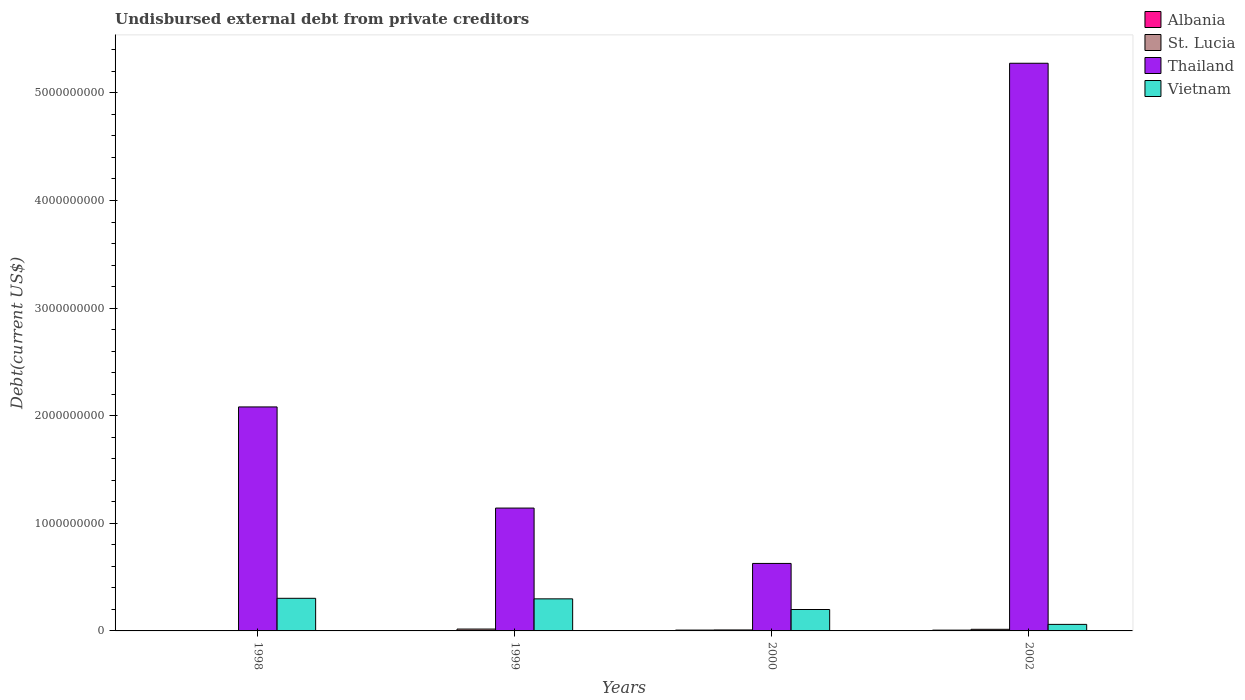How many different coloured bars are there?
Offer a terse response. 4. Are the number of bars per tick equal to the number of legend labels?
Give a very brief answer. Yes. Are the number of bars on each tick of the X-axis equal?
Make the answer very short. Yes. How many bars are there on the 4th tick from the left?
Keep it short and to the point. 4. In how many cases, is the number of bars for a given year not equal to the number of legend labels?
Offer a very short reply. 0. What is the total debt in Albania in 2000?
Offer a terse response. 7.78e+06. Across all years, what is the maximum total debt in Vietnam?
Offer a very short reply. 3.03e+08. Across all years, what is the minimum total debt in Thailand?
Keep it short and to the point. 6.27e+08. In which year was the total debt in Thailand maximum?
Keep it short and to the point. 2002. In which year was the total debt in Albania minimum?
Ensure brevity in your answer.  1999. What is the total total debt in Albania in the graph?
Make the answer very short. 1.59e+07. What is the difference between the total debt in St. Lucia in 1998 and that in 1999?
Your response must be concise. -1.43e+07. What is the difference between the total debt in Albania in 2000 and the total debt in St. Lucia in 1998?
Give a very brief answer. 4.71e+06. What is the average total debt in Albania per year?
Provide a succinct answer. 3.97e+06. In the year 1999, what is the difference between the total debt in Thailand and total debt in Albania?
Your answer should be compact. 1.14e+09. In how many years, is the total debt in Albania greater than 5200000000 US$?
Offer a terse response. 0. What is the ratio of the total debt in Vietnam in 1998 to that in 2002?
Provide a succinct answer. 4.99. What is the difference between the highest and the second highest total debt in Vietnam?
Ensure brevity in your answer.  5.08e+06. What is the difference between the highest and the lowest total debt in Vietnam?
Your answer should be compact. 2.42e+08. In how many years, is the total debt in Thailand greater than the average total debt in Thailand taken over all years?
Ensure brevity in your answer.  1. Is the sum of the total debt in Vietnam in 1999 and 2000 greater than the maximum total debt in St. Lucia across all years?
Offer a terse response. Yes. What does the 2nd bar from the left in 1999 represents?
Your answer should be very brief. St. Lucia. What does the 2nd bar from the right in 2000 represents?
Offer a very short reply. Thailand. How many bars are there?
Provide a short and direct response. 16. Are all the bars in the graph horizontal?
Your response must be concise. No. Are the values on the major ticks of Y-axis written in scientific E-notation?
Offer a very short reply. No. Does the graph contain grids?
Provide a short and direct response. No. How are the legend labels stacked?
Offer a terse response. Vertical. What is the title of the graph?
Your response must be concise. Undisbursed external debt from private creditors. Does "Maldives" appear as one of the legend labels in the graph?
Your answer should be compact. No. What is the label or title of the Y-axis?
Your response must be concise. Debt(current US$). What is the Debt(current US$) of Albania in 1998?
Provide a short and direct response. 4.29e+05. What is the Debt(current US$) of St. Lucia in 1998?
Your answer should be compact. 3.07e+06. What is the Debt(current US$) of Thailand in 1998?
Your response must be concise. 2.08e+09. What is the Debt(current US$) of Vietnam in 1998?
Provide a succinct answer. 3.03e+08. What is the Debt(current US$) in Albania in 1999?
Your response must be concise. 3.67e+05. What is the Debt(current US$) of St. Lucia in 1999?
Your answer should be very brief. 1.74e+07. What is the Debt(current US$) in Thailand in 1999?
Provide a succinct answer. 1.14e+09. What is the Debt(current US$) in Vietnam in 1999?
Make the answer very short. 2.98e+08. What is the Debt(current US$) of Albania in 2000?
Your answer should be compact. 7.78e+06. What is the Debt(current US$) of St. Lucia in 2000?
Your answer should be very brief. 9.00e+06. What is the Debt(current US$) of Thailand in 2000?
Provide a short and direct response. 6.27e+08. What is the Debt(current US$) of Vietnam in 2000?
Ensure brevity in your answer.  1.99e+08. What is the Debt(current US$) of Albania in 2002?
Provide a succinct answer. 7.31e+06. What is the Debt(current US$) in St. Lucia in 2002?
Offer a very short reply. 1.50e+07. What is the Debt(current US$) of Thailand in 2002?
Your response must be concise. 5.28e+09. What is the Debt(current US$) in Vietnam in 2002?
Give a very brief answer. 6.08e+07. Across all years, what is the maximum Debt(current US$) in Albania?
Ensure brevity in your answer.  7.78e+06. Across all years, what is the maximum Debt(current US$) in St. Lucia?
Offer a terse response. 1.74e+07. Across all years, what is the maximum Debt(current US$) of Thailand?
Give a very brief answer. 5.28e+09. Across all years, what is the maximum Debt(current US$) in Vietnam?
Your response must be concise. 3.03e+08. Across all years, what is the minimum Debt(current US$) in Albania?
Provide a succinct answer. 3.67e+05. Across all years, what is the minimum Debt(current US$) in St. Lucia?
Provide a succinct answer. 3.07e+06. Across all years, what is the minimum Debt(current US$) of Thailand?
Give a very brief answer. 6.27e+08. Across all years, what is the minimum Debt(current US$) of Vietnam?
Your answer should be compact. 6.08e+07. What is the total Debt(current US$) in Albania in the graph?
Ensure brevity in your answer.  1.59e+07. What is the total Debt(current US$) of St. Lucia in the graph?
Offer a very short reply. 4.45e+07. What is the total Debt(current US$) of Thailand in the graph?
Give a very brief answer. 9.13e+09. What is the total Debt(current US$) of Vietnam in the graph?
Provide a short and direct response. 8.61e+08. What is the difference between the Debt(current US$) in Albania in 1998 and that in 1999?
Keep it short and to the point. 6.20e+04. What is the difference between the Debt(current US$) in St. Lucia in 1998 and that in 1999?
Your response must be concise. -1.43e+07. What is the difference between the Debt(current US$) of Thailand in 1998 and that in 1999?
Ensure brevity in your answer.  9.40e+08. What is the difference between the Debt(current US$) of Vietnam in 1998 and that in 1999?
Your answer should be compact. 5.08e+06. What is the difference between the Debt(current US$) of Albania in 1998 and that in 2000?
Offer a terse response. -7.35e+06. What is the difference between the Debt(current US$) of St. Lucia in 1998 and that in 2000?
Your answer should be compact. -5.93e+06. What is the difference between the Debt(current US$) of Thailand in 1998 and that in 2000?
Provide a short and direct response. 1.45e+09. What is the difference between the Debt(current US$) in Vietnam in 1998 and that in 2000?
Ensure brevity in your answer.  1.04e+08. What is the difference between the Debt(current US$) in Albania in 1998 and that in 2002?
Make the answer very short. -6.88e+06. What is the difference between the Debt(current US$) of St. Lucia in 1998 and that in 2002?
Your answer should be compact. -1.19e+07. What is the difference between the Debt(current US$) in Thailand in 1998 and that in 2002?
Ensure brevity in your answer.  -3.19e+09. What is the difference between the Debt(current US$) in Vietnam in 1998 and that in 2002?
Provide a short and direct response. 2.42e+08. What is the difference between the Debt(current US$) of Albania in 1999 and that in 2000?
Make the answer very short. -7.41e+06. What is the difference between the Debt(current US$) in St. Lucia in 1999 and that in 2000?
Ensure brevity in your answer.  8.40e+06. What is the difference between the Debt(current US$) in Thailand in 1999 and that in 2000?
Your response must be concise. 5.14e+08. What is the difference between the Debt(current US$) in Vietnam in 1999 and that in 2000?
Your answer should be very brief. 9.90e+07. What is the difference between the Debt(current US$) of Albania in 1999 and that in 2002?
Provide a short and direct response. -6.95e+06. What is the difference between the Debt(current US$) of St. Lucia in 1999 and that in 2002?
Provide a succinct answer. 2.40e+06. What is the difference between the Debt(current US$) of Thailand in 1999 and that in 2002?
Your answer should be compact. -4.13e+09. What is the difference between the Debt(current US$) in Vietnam in 1999 and that in 2002?
Offer a terse response. 2.37e+08. What is the difference between the Debt(current US$) in Albania in 2000 and that in 2002?
Your response must be concise. 4.66e+05. What is the difference between the Debt(current US$) of St. Lucia in 2000 and that in 2002?
Offer a very short reply. -6.00e+06. What is the difference between the Debt(current US$) of Thailand in 2000 and that in 2002?
Provide a succinct answer. -4.65e+09. What is the difference between the Debt(current US$) of Vietnam in 2000 and that in 2002?
Your answer should be very brief. 1.38e+08. What is the difference between the Debt(current US$) of Albania in 1998 and the Debt(current US$) of St. Lucia in 1999?
Make the answer very short. -1.70e+07. What is the difference between the Debt(current US$) of Albania in 1998 and the Debt(current US$) of Thailand in 1999?
Make the answer very short. -1.14e+09. What is the difference between the Debt(current US$) in Albania in 1998 and the Debt(current US$) in Vietnam in 1999?
Provide a succinct answer. -2.98e+08. What is the difference between the Debt(current US$) of St. Lucia in 1998 and the Debt(current US$) of Thailand in 1999?
Give a very brief answer. -1.14e+09. What is the difference between the Debt(current US$) in St. Lucia in 1998 and the Debt(current US$) in Vietnam in 1999?
Provide a short and direct response. -2.95e+08. What is the difference between the Debt(current US$) of Thailand in 1998 and the Debt(current US$) of Vietnam in 1999?
Your response must be concise. 1.78e+09. What is the difference between the Debt(current US$) in Albania in 1998 and the Debt(current US$) in St. Lucia in 2000?
Ensure brevity in your answer.  -8.57e+06. What is the difference between the Debt(current US$) in Albania in 1998 and the Debt(current US$) in Thailand in 2000?
Provide a short and direct response. -6.27e+08. What is the difference between the Debt(current US$) in Albania in 1998 and the Debt(current US$) in Vietnam in 2000?
Offer a very short reply. -1.99e+08. What is the difference between the Debt(current US$) in St. Lucia in 1998 and the Debt(current US$) in Thailand in 2000?
Give a very brief answer. -6.24e+08. What is the difference between the Debt(current US$) of St. Lucia in 1998 and the Debt(current US$) of Vietnam in 2000?
Make the answer very short. -1.96e+08. What is the difference between the Debt(current US$) in Thailand in 1998 and the Debt(current US$) in Vietnam in 2000?
Provide a short and direct response. 1.88e+09. What is the difference between the Debt(current US$) in Albania in 1998 and the Debt(current US$) in St. Lucia in 2002?
Offer a terse response. -1.46e+07. What is the difference between the Debt(current US$) of Albania in 1998 and the Debt(current US$) of Thailand in 2002?
Provide a short and direct response. -5.28e+09. What is the difference between the Debt(current US$) of Albania in 1998 and the Debt(current US$) of Vietnam in 2002?
Offer a very short reply. -6.03e+07. What is the difference between the Debt(current US$) of St. Lucia in 1998 and the Debt(current US$) of Thailand in 2002?
Ensure brevity in your answer.  -5.27e+09. What is the difference between the Debt(current US$) of St. Lucia in 1998 and the Debt(current US$) of Vietnam in 2002?
Your answer should be very brief. -5.77e+07. What is the difference between the Debt(current US$) of Thailand in 1998 and the Debt(current US$) of Vietnam in 2002?
Make the answer very short. 2.02e+09. What is the difference between the Debt(current US$) in Albania in 1999 and the Debt(current US$) in St. Lucia in 2000?
Ensure brevity in your answer.  -8.63e+06. What is the difference between the Debt(current US$) of Albania in 1999 and the Debt(current US$) of Thailand in 2000?
Make the answer very short. -6.27e+08. What is the difference between the Debt(current US$) of Albania in 1999 and the Debt(current US$) of Vietnam in 2000?
Provide a short and direct response. -1.99e+08. What is the difference between the Debt(current US$) of St. Lucia in 1999 and the Debt(current US$) of Thailand in 2000?
Provide a short and direct response. -6.10e+08. What is the difference between the Debt(current US$) in St. Lucia in 1999 and the Debt(current US$) in Vietnam in 2000?
Give a very brief answer. -1.82e+08. What is the difference between the Debt(current US$) in Thailand in 1999 and the Debt(current US$) in Vietnam in 2000?
Ensure brevity in your answer.  9.43e+08. What is the difference between the Debt(current US$) of Albania in 1999 and the Debt(current US$) of St. Lucia in 2002?
Keep it short and to the point. -1.46e+07. What is the difference between the Debt(current US$) of Albania in 1999 and the Debt(current US$) of Thailand in 2002?
Keep it short and to the point. -5.28e+09. What is the difference between the Debt(current US$) in Albania in 1999 and the Debt(current US$) in Vietnam in 2002?
Provide a short and direct response. -6.04e+07. What is the difference between the Debt(current US$) in St. Lucia in 1999 and the Debt(current US$) in Thailand in 2002?
Make the answer very short. -5.26e+09. What is the difference between the Debt(current US$) in St. Lucia in 1999 and the Debt(current US$) in Vietnam in 2002?
Provide a succinct answer. -4.34e+07. What is the difference between the Debt(current US$) of Thailand in 1999 and the Debt(current US$) of Vietnam in 2002?
Ensure brevity in your answer.  1.08e+09. What is the difference between the Debt(current US$) of Albania in 2000 and the Debt(current US$) of St. Lucia in 2002?
Provide a succinct answer. -7.22e+06. What is the difference between the Debt(current US$) in Albania in 2000 and the Debt(current US$) in Thailand in 2002?
Keep it short and to the point. -5.27e+09. What is the difference between the Debt(current US$) of Albania in 2000 and the Debt(current US$) of Vietnam in 2002?
Ensure brevity in your answer.  -5.30e+07. What is the difference between the Debt(current US$) in St. Lucia in 2000 and the Debt(current US$) in Thailand in 2002?
Provide a short and direct response. -5.27e+09. What is the difference between the Debt(current US$) in St. Lucia in 2000 and the Debt(current US$) in Vietnam in 2002?
Offer a very short reply. -5.18e+07. What is the difference between the Debt(current US$) in Thailand in 2000 and the Debt(current US$) in Vietnam in 2002?
Offer a terse response. 5.67e+08. What is the average Debt(current US$) in Albania per year?
Ensure brevity in your answer.  3.97e+06. What is the average Debt(current US$) in St. Lucia per year?
Your answer should be compact. 1.11e+07. What is the average Debt(current US$) of Thailand per year?
Offer a very short reply. 2.28e+09. What is the average Debt(current US$) of Vietnam per year?
Provide a succinct answer. 2.15e+08. In the year 1998, what is the difference between the Debt(current US$) in Albania and Debt(current US$) in St. Lucia?
Make the answer very short. -2.64e+06. In the year 1998, what is the difference between the Debt(current US$) of Albania and Debt(current US$) of Thailand?
Provide a succinct answer. -2.08e+09. In the year 1998, what is the difference between the Debt(current US$) in Albania and Debt(current US$) in Vietnam?
Offer a terse response. -3.03e+08. In the year 1998, what is the difference between the Debt(current US$) in St. Lucia and Debt(current US$) in Thailand?
Make the answer very short. -2.08e+09. In the year 1998, what is the difference between the Debt(current US$) of St. Lucia and Debt(current US$) of Vietnam?
Offer a terse response. -3.00e+08. In the year 1998, what is the difference between the Debt(current US$) in Thailand and Debt(current US$) in Vietnam?
Your response must be concise. 1.78e+09. In the year 1999, what is the difference between the Debt(current US$) in Albania and Debt(current US$) in St. Lucia?
Keep it short and to the point. -1.70e+07. In the year 1999, what is the difference between the Debt(current US$) of Albania and Debt(current US$) of Thailand?
Keep it short and to the point. -1.14e+09. In the year 1999, what is the difference between the Debt(current US$) in Albania and Debt(current US$) in Vietnam?
Keep it short and to the point. -2.98e+08. In the year 1999, what is the difference between the Debt(current US$) of St. Lucia and Debt(current US$) of Thailand?
Offer a very short reply. -1.12e+09. In the year 1999, what is the difference between the Debt(current US$) of St. Lucia and Debt(current US$) of Vietnam?
Offer a very short reply. -2.81e+08. In the year 1999, what is the difference between the Debt(current US$) in Thailand and Debt(current US$) in Vietnam?
Your answer should be compact. 8.44e+08. In the year 2000, what is the difference between the Debt(current US$) of Albania and Debt(current US$) of St. Lucia?
Offer a very short reply. -1.22e+06. In the year 2000, what is the difference between the Debt(current US$) in Albania and Debt(current US$) in Thailand?
Keep it short and to the point. -6.20e+08. In the year 2000, what is the difference between the Debt(current US$) of Albania and Debt(current US$) of Vietnam?
Give a very brief answer. -1.91e+08. In the year 2000, what is the difference between the Debt(current US$) in St. Lucia and Debt(current US$) in Thailand?
Offer a terse response. -6.18e+08. In the year 2000, what is the difference between the Debt(current US$) in St. Lucia and Debt(current US$) in Vietnam?
Provide a short and direct response. -1.90e+08. In the year 2000, what is the difference between the Debt(current US$) of Thailand and Debt(current US$) of Vietnam?
Provide a succinct answer. 4.28e+08. In the year 2002, what is the difference between the Debt(current US$) in Albania and Debt(current US$) in St. Lucia?
Provide a short and direct response. -7.69e+06. In the year 2002, what is the difference between the Debt(current US$) of Albania and Debt(current US$) of Thailand?
Provide a short and direct response. -5.27e+09. In the year 2002, what is the difference between the Debt(current US$) of Albania and Debt(current US$) of Vietnam?
Offer a terse response. -5.34e+07. In the year 2002, what is the difference between the Debt(current US$) of St. Lucia and Debt(current US$) of Thailand?
Provide a short and direct response. -5.26e+09. In the year 2002, what is the difference between the Debt(current US$) of St. Lucia and Debt(current US$) of Vietnam?
Offer a very short reply. -4.58e+07. In the year 2002, what is the difference between the Debt(current US$) in Thailand and Debt(current US$) in Vietnam?
Make the answer very short. 5.21e+09. What is the ratio of the Debt(current US$) in Albania in 1998 to that in 1999?
Provide a short and direct response. 1.17. What is the ratio of the Debt(current US$) of St. Lucia in 1998 to that in 1999?
Keep it short and to the point. 0.18. What is the ratio of the Debt(current US$) of Thailand in 1998 to that in 1999?
Your answer should be very brief. 1.82. What is the ratio of the Debt(current US$) of Vietnam in 1998 to that in 1999?
Ensure brevity in your answer.  1.02. What is the ratio of the Debt(current US$) of Albania in 1998 to that in 2000?
Keep it short and to the point. 0.06. What is the ratio of the Debt(current US$) in St. Lucia in 1998 to that in 2000?
Make the answer very short. 0.34. What is the ratio of the Debt(current US$) of Thailand in 1998 to that in 2000?
Ensure brevity in your answer.  3.32. What is the ratio of the Debt(current US$) of Vietnam in 1998 to that in 2000?
Make the answer very short. 1.52. What is the ratio of the Debt(current US$) in Albania in 1998 to that in 2002?
Your answer should be compact. 0.06. What is the ratio of the Debt(current US$) of St. Lucia in 1998 to that in 2002?
Provide a short and direct response. 0.2. What is the ratio of the Debt(current US$) of Thailand in 1998 to that in 2002?
Give a very brief answer. 0.39. What is the ratio of the Debt(current US$) of Vietnam in 1998 to that in 2002?
Make the answer very short. 4.99. What is the ratio of the Debt(current US$) in Albania in 1999 to that in 2000?
Provide a short and direct response. 0.05. What is the ratio of the Debt(current US$) of St. Lucia in 1999 to that in 2000?
Keep it short and to the point. 1.93. What is the ratio of the Debt(current US$) of Thailand in 1999 to that in 2000?
Offer a terse response. 1.82. What is the ratio of the Debt(current US$) of Vietnam in 1999 to that in 2000?
Offer a terse response. 1.5. What is the ratio of the Debt(current US$) in Albania in 1999 to that in 2002?
Ensure brevity in your answer.  0.05. What is the ratio of the Debt(current US$) of St. Lucia in 1999 to that in 2002?
Offer a terse response. 1.16. What is the ratio of the Debt(current US$) of Thailand in 1999 to that in 2002?
Provide a short and direct response. 0.22. What is the ratio of the Debt(current US$) of Vietnam in 1999 to that in 2002?
Give a very brief answer. 4.9. What is the ratio of the Debt(current US$) in Albania in 2000 to that in 2002?
Offer a very short reply. 1.06. What is the ratio of the Debt(current US$) in Thailand in 2000 to that in 2002?
Your answer should be very brief. 0.12. What is the ratio of the Debt(current US$) in Vietnam in 2000 to that in 2002?
Your response must be concise. 3.27. What is the difference between the highest and the second highest Debt(current US$) of Albania?
Give a very brief answer. 4.66e+05. What is the difference between the highest and the second highest Debt(current US$) of St. Lucia?
Offer a terse response. 2.40e+06. What is the difference between the highest and the second highest Debt(current US$) of Thailand?
Offer a terse response. 3.19e+09. What is the difference between the highest and the second highest Debt(current US$) of Vietnam?
Keep it short and to the point. 5.08e+06. What is the difference between the highest and the lowest Debt(current US$) of Albania?
Your answer should be very brief. 7.41e+06. What is the difference between the highest and the lowest Debt(current US$) in St. Lucia?
Keep it short and to the point. 1.43e+07. What is the difference between the highest and the lowest Debt(current US$) in Thailand?
Keep it short and to the point. 4.65e+09. What is the difference between the highest and the lowest Debt(current US$) of Vietnam?
Your answer should be very brief. 2.42e+08. 